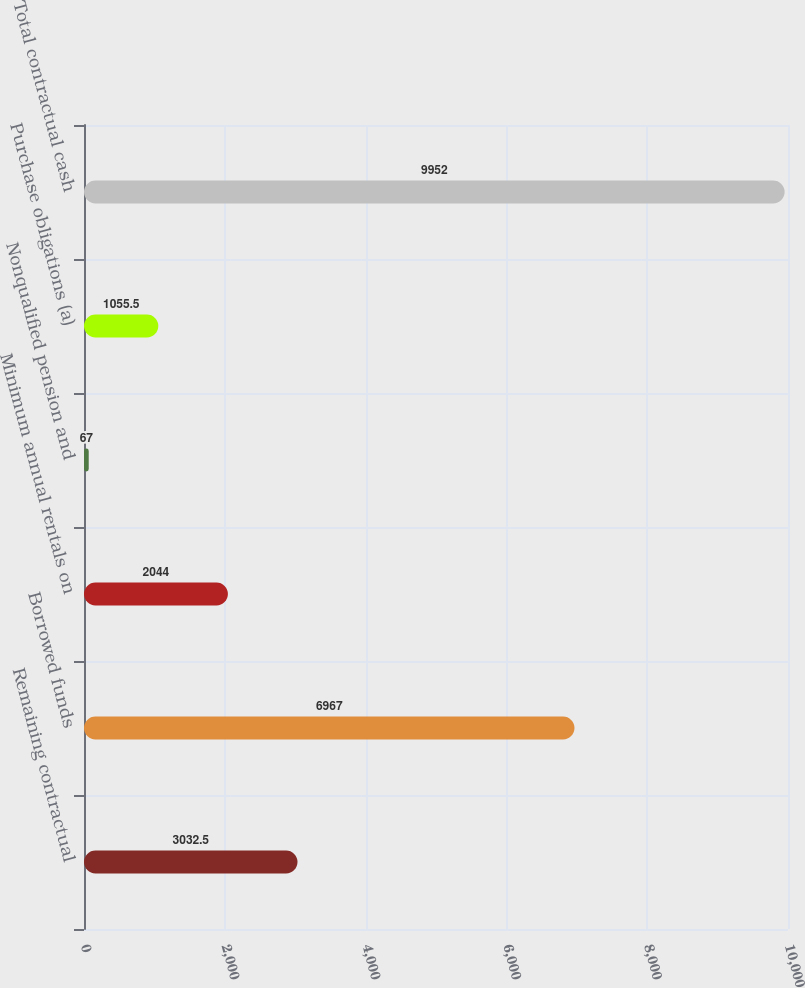Convert chart to OTSL. <chart><loc_0><loc_0><loc_500><loc_500><bar_chart><fcel>Remaining contractual<fcel>Borrowed funds<fcel>Minimum annual rentals on<fcel>Nonqualified pension and<fcel>Purchase obligations (a)<fcel>Total contractual cash<nl><fcel>3032.5<fcel>6967<fcel>2044<fcel>67<fcel>1055.5<fcel>9952<nl></chart> 